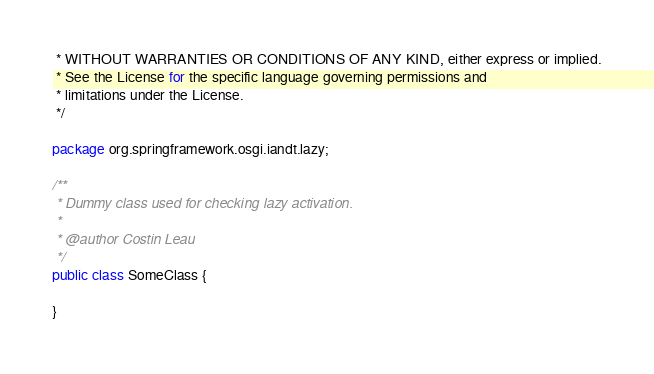Convert code to text. <code><loc_0><loc_0><loc_500><loc_500><_Java_> * WITHOUT WARRANTIES OR CONDITIONS OF ANY KIND, either express or implied.
 * See the License for the specific language governing permissions and
 * limitations under the License.
 */

package org.springframework.osgi.iandt.lazy;

/**
 * Dummy class used for checking lazy activation.
 * 
 * @author Costin Leau
 */
public class SomeClass {

}
</code> 